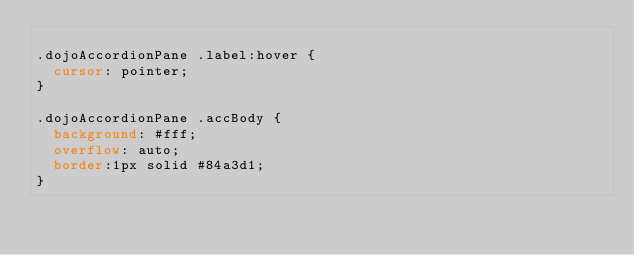<code> <loc_0><loc_0><loc_500><loc_500><_CSS_>
.dojoAccordionPane .label:hover {
	cursor: pointer;
}

.dojoAccordionPane .accBody {
	background: #fff;
	overflow: auto;
	border:1px solid #84a3d1;
}
</code> 